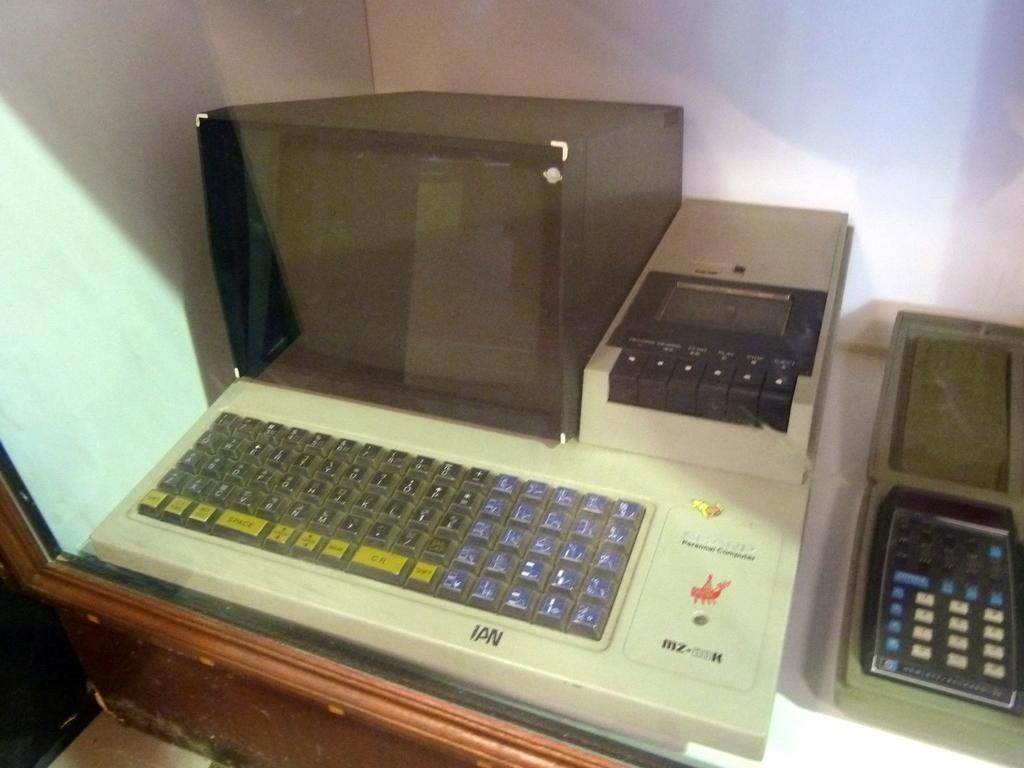<image>
Share a concise interpretation of the image provided. An old fashioned Sharp Personal computer sits on a desk. 